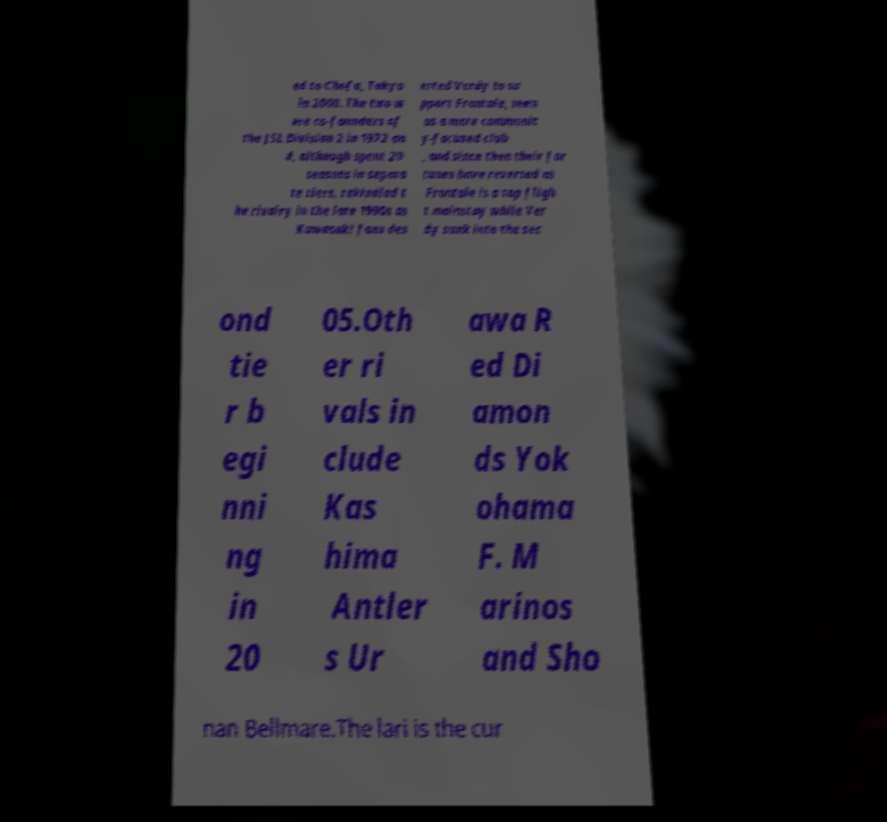Could you assist in decoding the text presented in this image and type it out clearly? ed to Chofu, Tokyo in 2000. The two w ere co-founders of the JSL Division 2 in 1972 an d, although spent 20 seasons in separa te tiers, rekindled t he rivalry in the late 1990s as Kawasaki fans des erted Verdy to su pport Frontale, seen as a more communit y-focused club , and since then their for tunes have reversed as Frontale is a top fligh t mainstay while Ver dy sunk into the sec ond tie r b egi nni ng in 20 05.Oth er ri vals in clude Kas hima Antler s Ur awa R ed Di amon ds Yok ohama F. M arinos and Sho nan Bellmare.The lari is the cur 